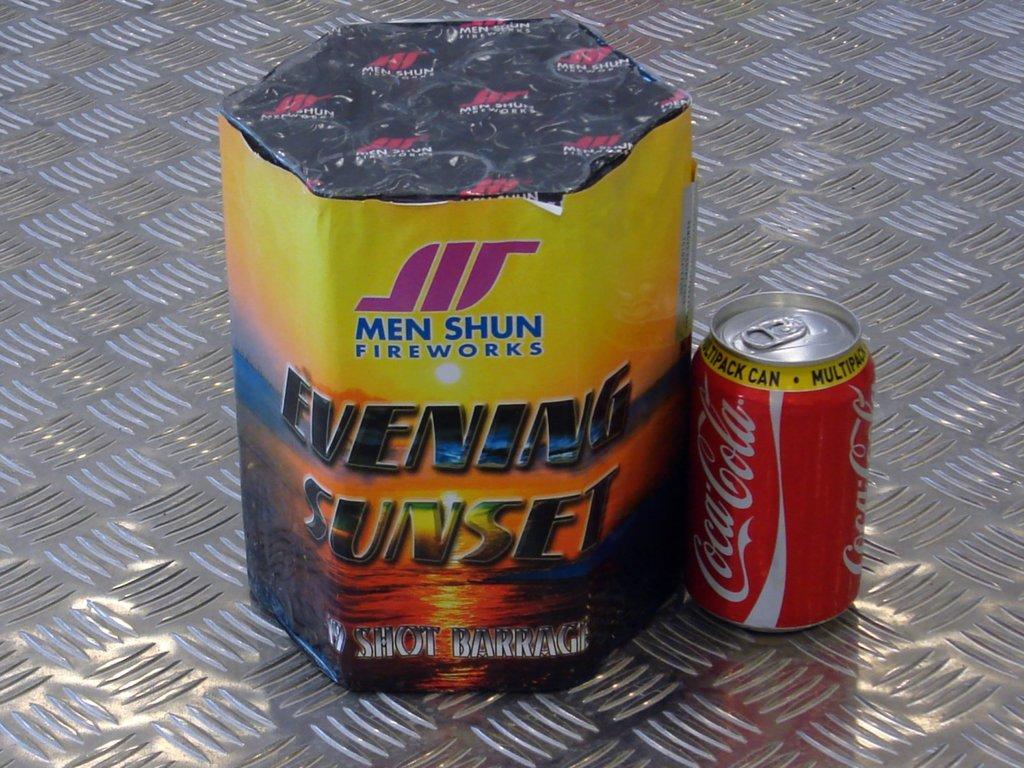What kind of fireworks are those?
Your answer should be compact. Men shun. What is the name of the drink next to fireworks?
Ensure brevity in your answer.  Coca cola. 